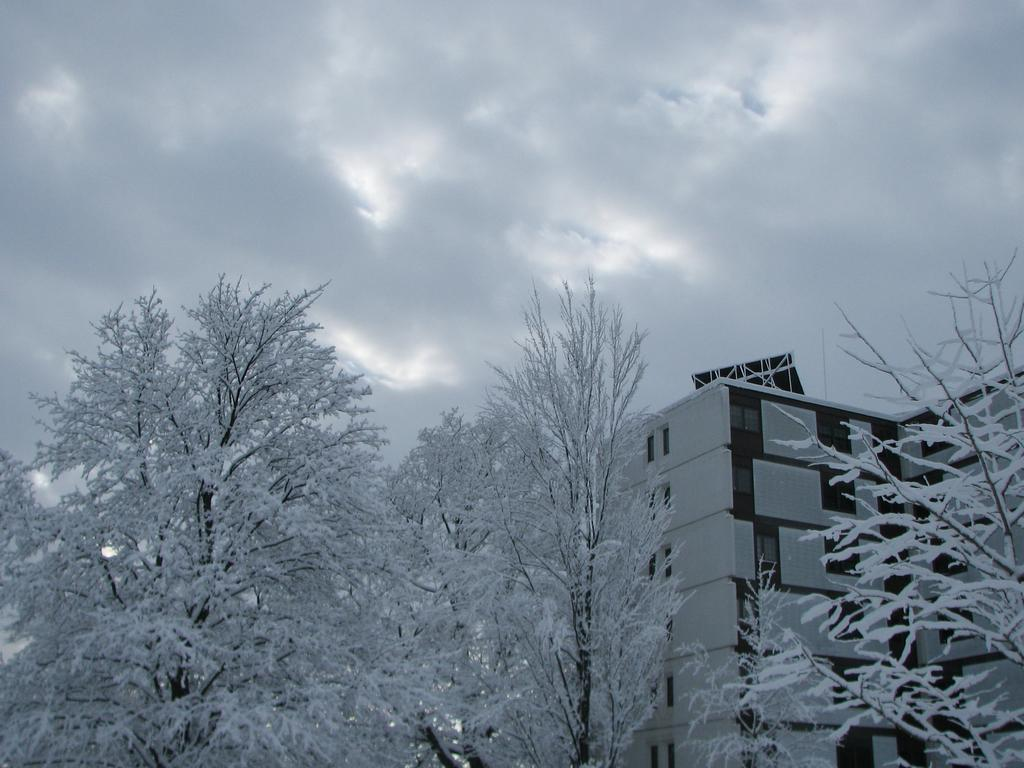What is the condition of the trees in the image? The trees in the image are covered with snow. What structure can be seen on the right side of the image? There is a building on the right side of the image. How would you describe the sky in the image? The sky is cloudy in the image. Can you tell me how many geese are talking to the guide in the image? There are no geese or guides present in the image. What type of goose can be seen guiding the building in the image? There is no goose or building interaction depicted in the image. 